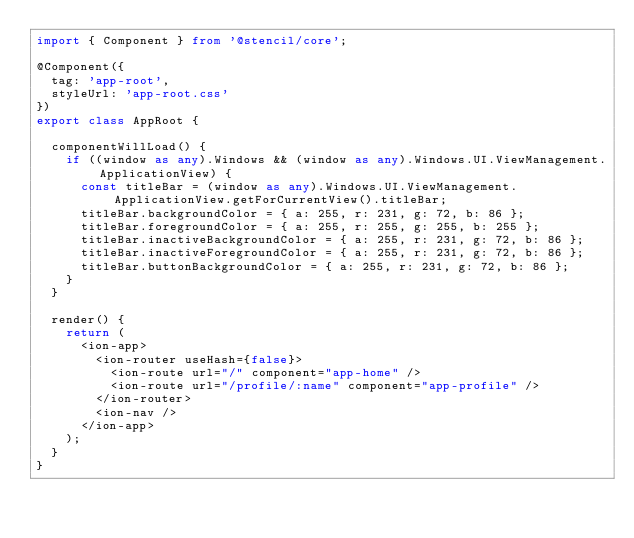Convert code to text. <code><loc_0><loc_0><loc_500><loc_500><_TypeScript_>import { Component } from '@stencil/core';

@Component({
  tag: 'app-root',
  styleUrl: 'app-root.css'
})
export class AppRoot {

  componentWillLoad() {
    if ((window as any).Windows && (window as any).Windows.UI.ViewManagement.ApplicationView) {
      const titleBar = (window as any).Windows.UI.ViewManagement.ApplicationView.getForCurrentView().titleBar;
      titleBar.backgroundColor = { a: 255, r: 231, g: 72, b: 86 };
      titleBar.foregroundColor = { a: 255, r: 255, g: 255, b: 255 };
      titleBar.inactiveBackgroundColor = { a: 255, r: 231, g: 72, b: 86 };
      titleBar.inactiveForegroundColor = { a: 255, r: 231, g: 72, b: 86 };
      titleBar.buttonBackgroundColor = { a: 255, r: 231, g: 72, b: 86 };
    }
  }

  render() {
    return (
      <ion-app>
        <ion-router useHash={false}>
          <ion-route url="/" component="app-home" />
          <ion-route url="/profile/:name" component="app-profile" />
        </ion-router>
        <ion-nav />
      </ion-app>
    );
  }
}
</code> 